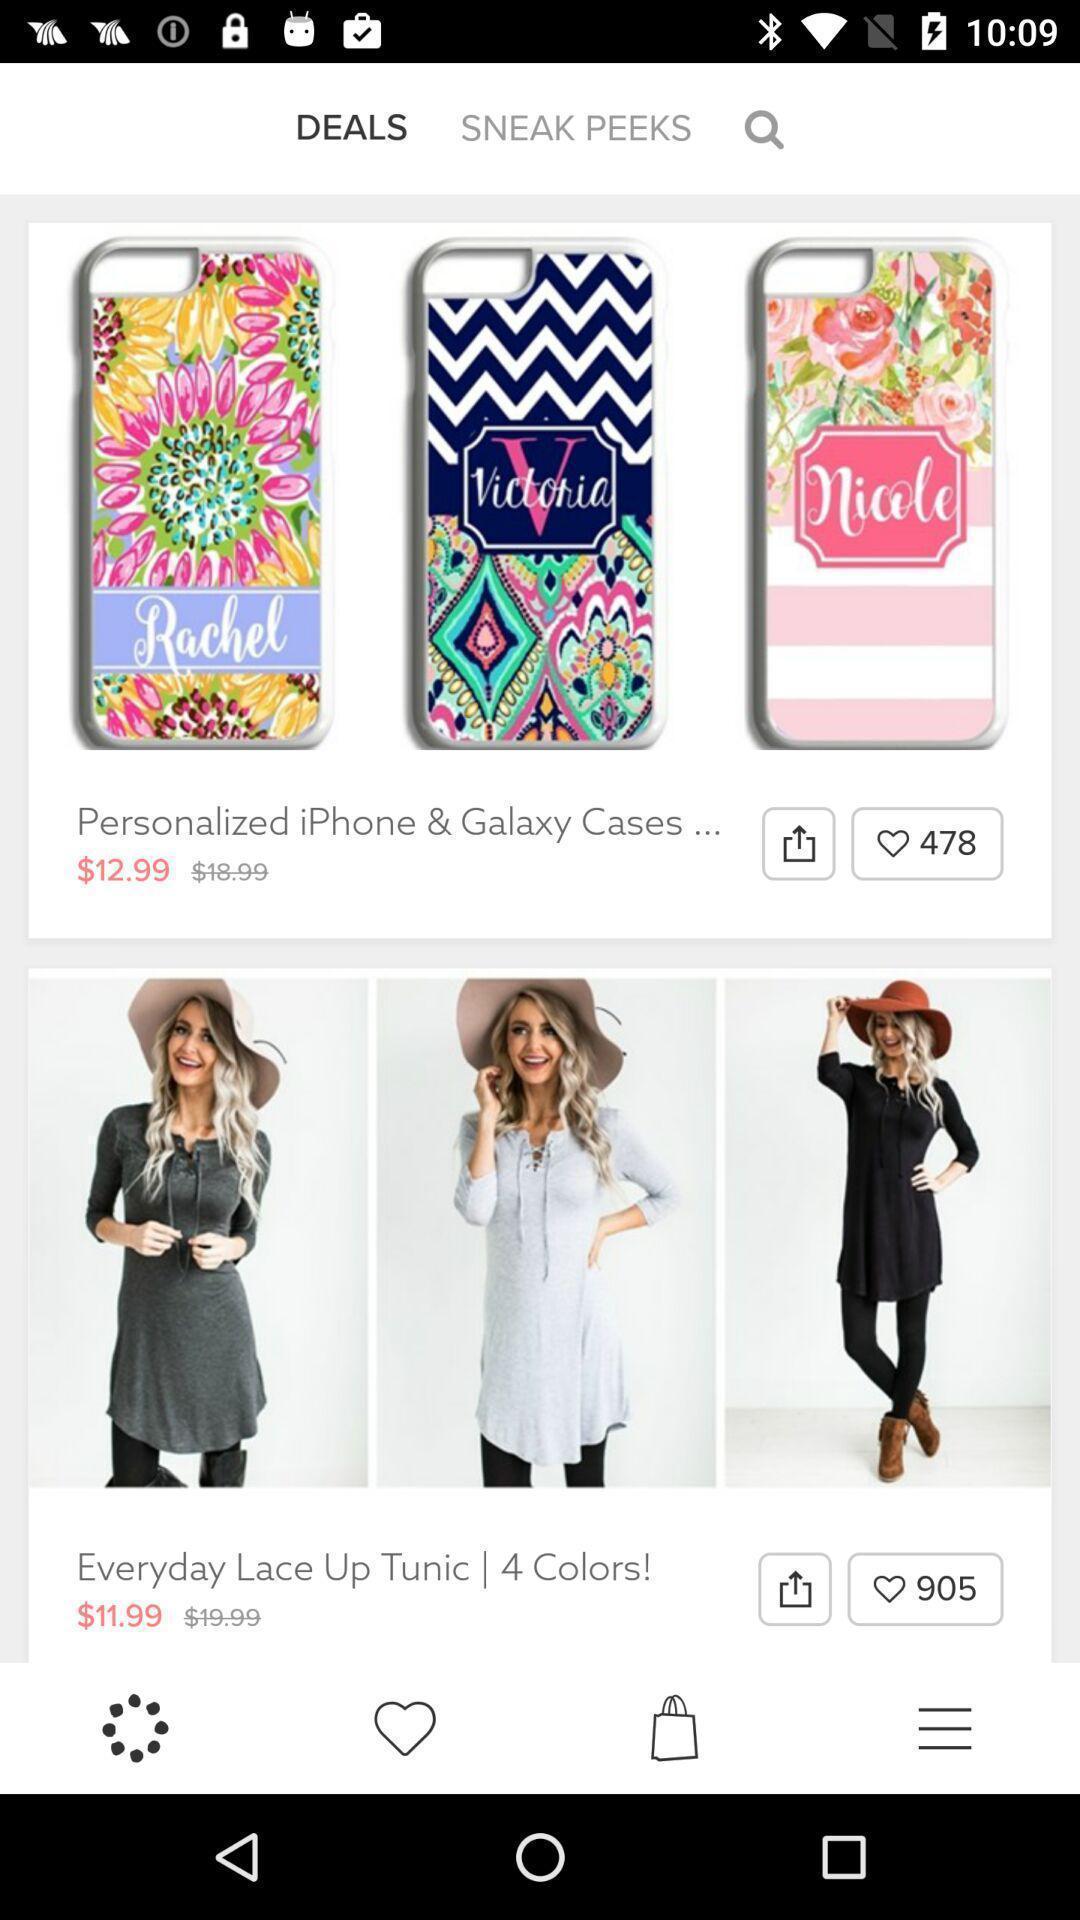Describe this image in words. Screen shows different images in shopping app. 